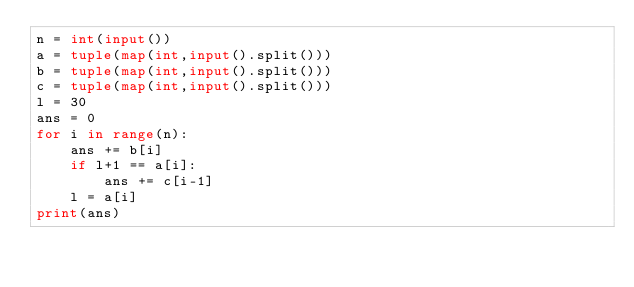Convert code to text. <code><loc_0><loc_0><loc_500><loc_500><_Python_>n = int(input())
a = tuple(map(int,input().split()))
b = tuple(map(int,input().split()))
c = tuple(map(int,input().split()))
l = 30
ans = 0
for i in range(n):
    ans += b[i]
    if l+1 == a[i]:
        ans += c[i-1]
    l = a[i]
print(ans)</code> 